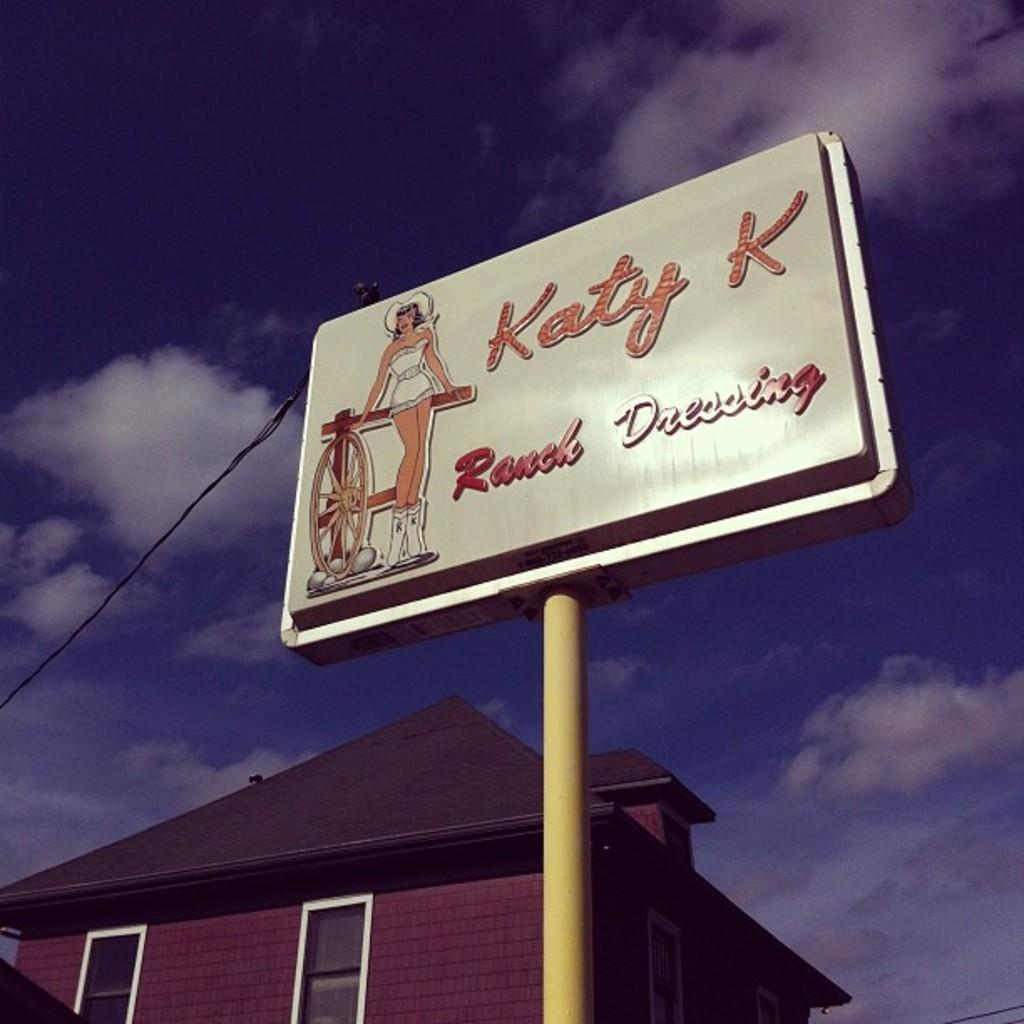<image>
Render a clear and concise summary of the photo. A sign next to a building with a picture of a woman in a small outfit advertising Katy K Ranch Dressing. 